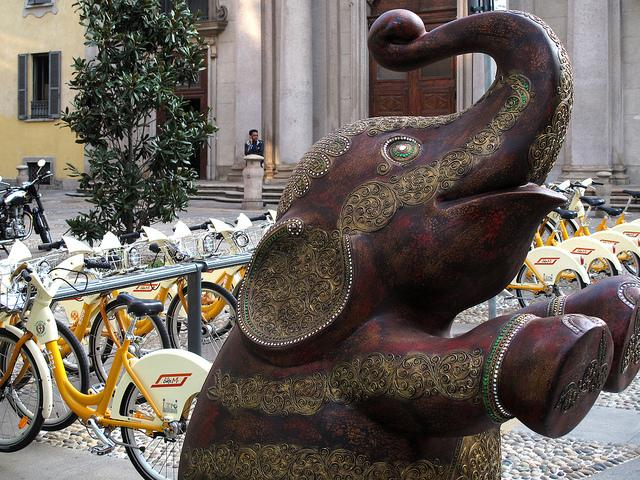The statue best represents who? elephant 